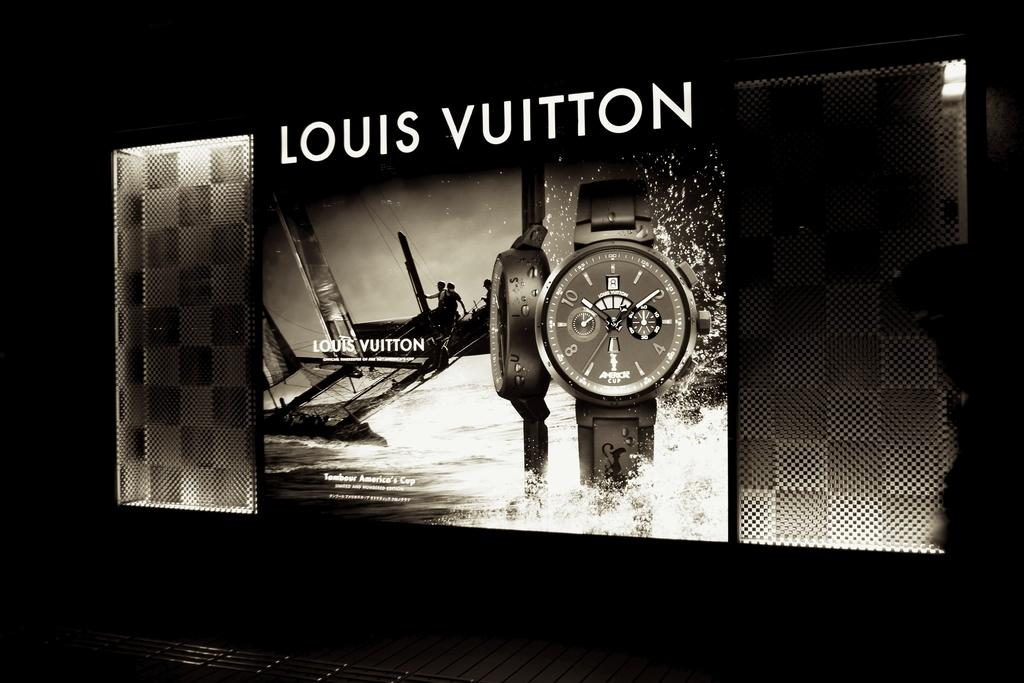<image>
Describe the image concisely. a Louis Vuitton iluminated ad displaying its watches 